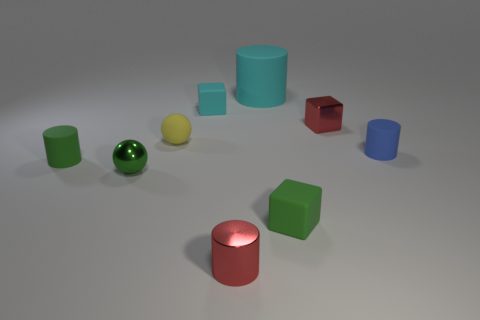There is a thing that is the same color as the large cylinder; what shape is it?
Make the answer very short. Cube. How many green metallic things are the same size as the blue rubber cylinder?
Provide a short and direct response. 1. Are there fewer cyan things in front of the green sphere than big objects?
Your answer should be compact. Yes. There is a large matte cylinder; how many spheres are behind it?
Offer a terse response. 0. How big is the metal thing left of the shiny cylinder that is to the right of the small rubber block that is on the left side of the big cylinder?
Your answer should be very brief. Small. There is a tiny yellow rubber thing; is its shape the same as the small shiny thing to the right of the large rubber cylinder?
Offer a very short reply. No. What size is the sphere that is made of the same material as the tiny green cube?
Your answer should be very brief. Small. Are there any other things that are the same color as the small metallic cube?
Provide a succinct answer. Yes. What material is the small block in front of the small rubber object that is on the right side of the tiny rubber block in front of the tiny red shiny cube?
Provide a short and direct response. Rubber. How many metallic objects are either spheres or tiny cubes?
Ensure brevity in your answer.  2. 